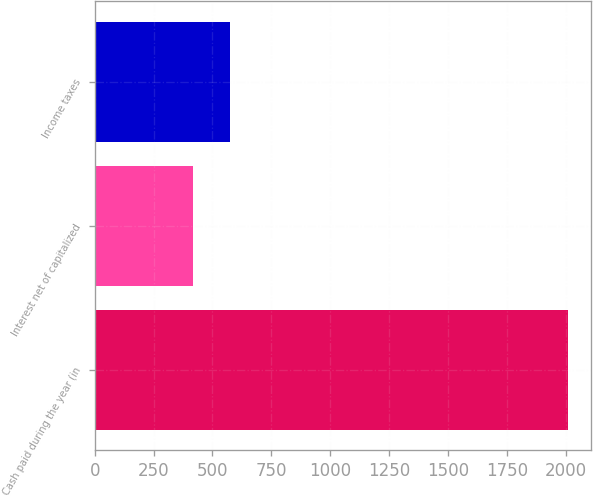Convert chart. <chart><loc_0><loc_0><loc_500><loc_500><bar_chart><fcel>Cash paid during the year (in<fcel>Interest net of capitalized<fcel>Income taxes<nl><fcel>2009<fcel>416<fcel>575.3<nl></chart> 